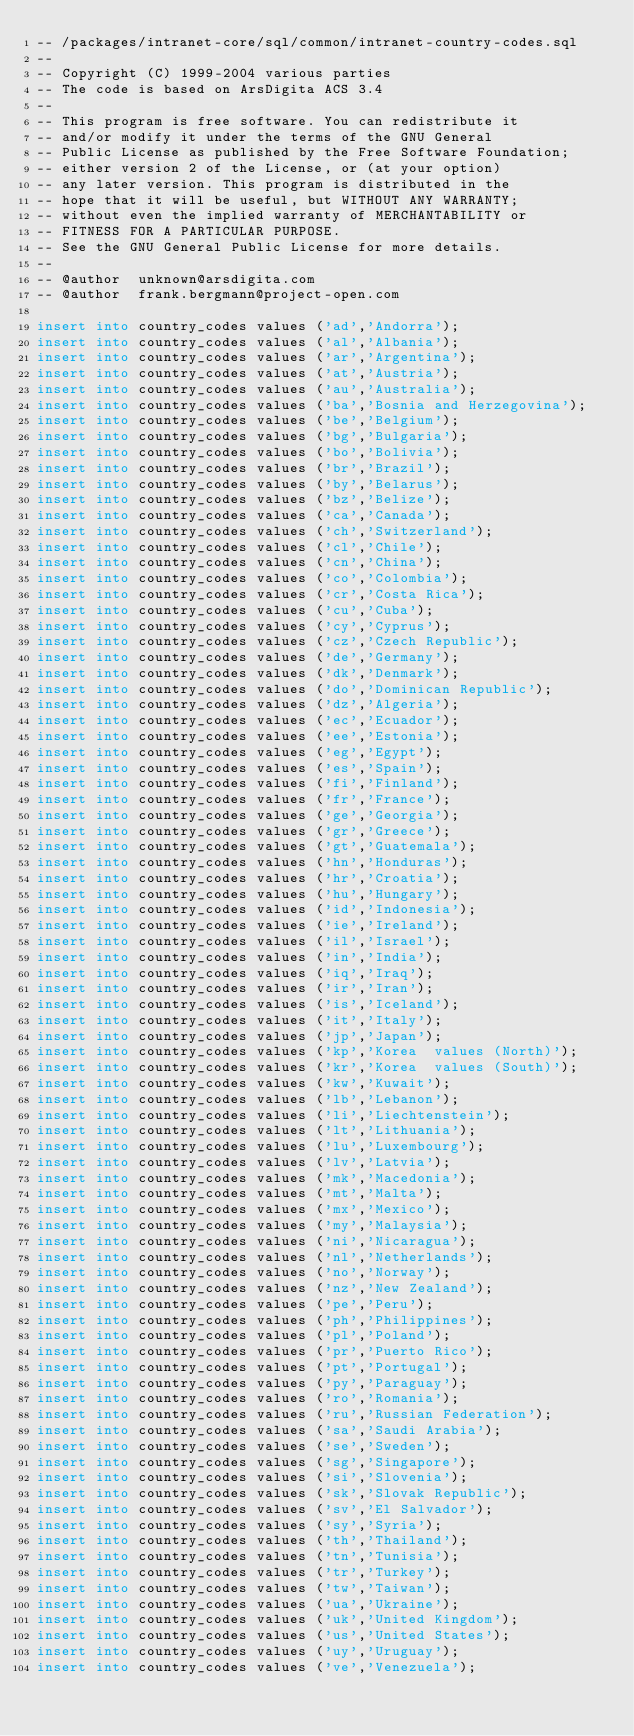Convert code to text. <code><loc_0><loc_0><loc_500><loc_500><_SQL_>-- /packages/intranet-core/sql/common/intranet-country-codes.sql
--
-- Copyright (C) 1999-2004 various parties
-- The code is based on ArsDigita ACS 3.4
--
-- This program is free software. You can redistribute it 
-- and/or modify it under the terms of the GNU General 
-- Public License as published by the Free Software Foundation; 
-- either version 2 of the License, or (at your option) 
-- any later version. This program is distributed in the 
-- hope that it will be useful, but WITHOUT ANY WARRANTY; 
-- without even the implied warranty of MERCHANTABILITY or 
-- FITNESS FOR A PARTICULAR PURPOSE. 
-- See the GNU General Public License for more details.
--
-- @author	unknown@arsdigita.com
-- @author	frank.bergmann@project-open.com

insert into country_codes values ('ad','Andorra');
insert into country_codes values ('al','Albania');
insert into country_codes values ('ar','Argentina');
insert into country_codes values ('at','Austria');
insert into country_codes values ('au','Australia');
insert into country_codes values ('ba','Bosnia and Herzegovina');
insert into country_codes values ('be','Belgium');
insert into country_codes values ('bg','Bulgaria');
insert into country_codes values ('bo','Bolivia');
insert into country_codes values ('br','Brazil');
insert into country_codes values ('by','Belarus');
insert into country_codes values ('bz','Belize');
insert into country_codes values ('ca','Canada');
insert into country_codes values ('ch','Switzerland');
insert into country_codes values ('cl','Chile');
insert into country_codes values ('cn','China');
insert into country_codes values ('co','Colombia');
insert into country_codes values ('cr','Costa Rica');
insert into country_codes values ('cu','Cuba');
insert into country_codes values ('cy','Cyprus');
insert into country_codes values ('cz','Czech Republic');
insert into country_codes values ('de','Germany');
insert into country_codes values ('dk','Denmark');
insert into country_codes values ('do','Dominican Republic');
insert into country_codes values ('dz','Algeria');
insert into country_codes values ('ec','Ecuador');
insert into country_codes values ('ee','Estonia');
insert into country_codes values ('eg','Egypt');
insert into country_codes values ('es','Spain');
insert into country_codes values ('fi','Finland');
insert into country_codes values ('fr','France');
insert into country_codes values ('ge','Georgia');
insert into country_codes values ('gr','Greece');
insert into country_codes values ('gt','Guatemala');
insert into country_codes values ('hn','Honduras');
insert into country_codes values ('hr','Croatia');
insert into country_codes values ('hu','Hungary');
insert into country_codes values ('id','Indonesia');
insert into country_codes values ('ie','Ireland');
insert into country_codes values ('il','Israel');
insert into country_codes values ('in','India');
insert into country_codes values ('iq','Iraq');
insert into country_codes values ('ir','Iran');
insert into country_codes values ('is','Iceland');
insert into country_codes values ('it','Italy');
insert into country_codes values ('jp','Japan');
insert into country_codes values ('kp','Korea  values (North)');
insert into country_codes values ('kr','Korea  values (South)');
insert into country_codes values ('kw','Kuwait');
insert into country_codes values ('lb','Lebanon');
insert into country_codes values ('li','Liechtenstein');
insert into country_codes values ('lt','Lithuania');
insert into country_codes values ('lu','Luxembourg');
insert into country_codes values ('lv','Latvia');
insert into country_codes values ('mk','Macedonia');
insert into country_codes values ('mt','Malta');
insert into country_codes values ('mx','Mexico');
insert into country_codes values ('my','Malaysia');
insert into country_codes values ('ni','Nicaragua');
insert into country_codes values ('nl','Netherlands');
insert into country_codes values ('no','Norway');
insert into country_codes values ('nz','New Zealand');
insert into country_codes values ('pe','Peru');
insert into country_codes values ('ph','Philippines');
insert into country_codes values ('pl','Poland');
insert into country_codes values ('pr','Puerto Rico');
insert into country_codes values ('pt','Portugal');
insert into country_codes values ('py','Paraguay');
insert into country_codes values ('ro','Romania');
insert into country_codes values ('ru','Russian Federation');
insert into country_codes values ('sa','Saudi Arabia');
insert into country_codes values ('se','Sweden');
insert into country_codes values ('sg','Singapore');
insert into country_codes values ('si','Slovenia');
insert into country_codes values ('sk','Slovak Republic');
insert into country_codes values ('sv','El Salvador');
insert into country_codes values ('sy','Syria');
insert into country_codes values ('th','Thailand');
insert into country_codes values ('tn','Tunisia');
insert into country_codes values ('tr','Turkey');
insert into country_codes values ('tw','Taiwan');
insert into country_codes values ('ua','Ukraine');
insert into country_codes values ('uk','United Kingdom');
insert into country_codes values ('us','United States');
insert into country_codes values ('uy','Uruguay');
insert into country_codes values ('ve','Venezuela');</code> 